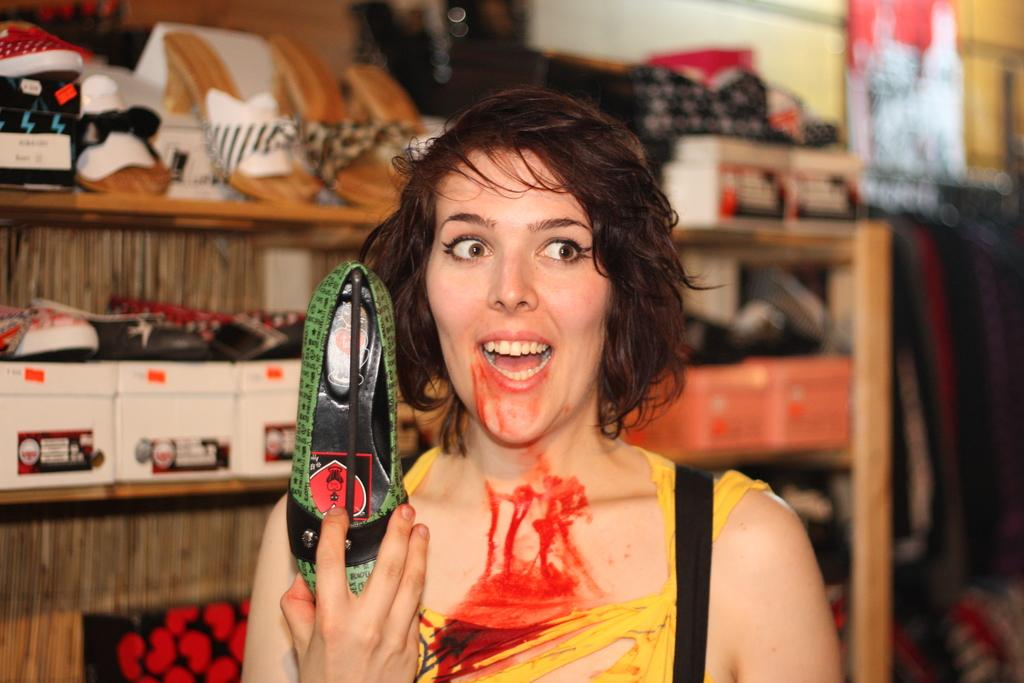Who or what is the main subject in the image? There is a person in the image. What else can be seen in the image besides the person? There is an object in the image. What type of footwear can be seen in the background of the image? There are shoes and sandals in the background of the image. What type of storage or display feature is present in the background of the image? There are shelves in the background of the image. What other objects can be seen in the background of the image? There are other objects in the background of the image. What type of car can be seen in the image? There is no car present in the image. How does the person in the image use a comb? There is no comb present in the image. 